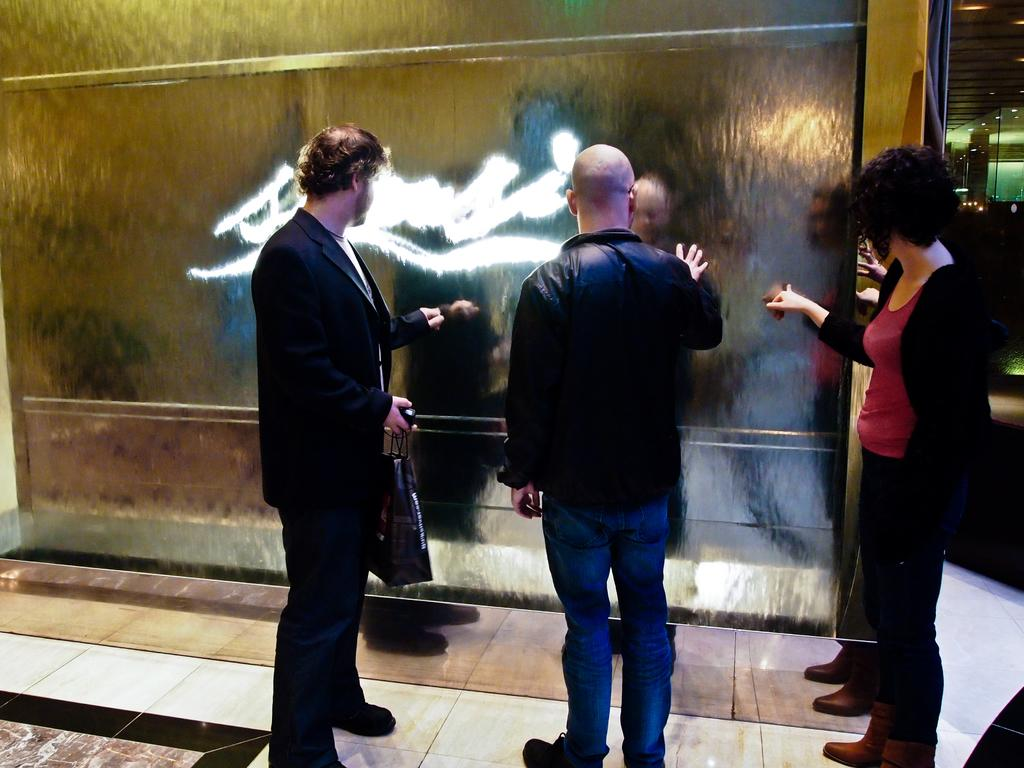How many people are in the image? There are three persons in the image. What are the persons doing in the image? The persons are standing. What are the persons wearing in the image? The persons are wearing clothes. What is the person in the middle of the image holding? The person in the middle of the image is holding a bag with his hand. What type of wine is being served in the image? There is no wine present in the image. What kind of shoe is the person in the middle wearing? There is no shoe visible in the image, as the persons are wearing clothes, but no specific footwear is mentioned. 